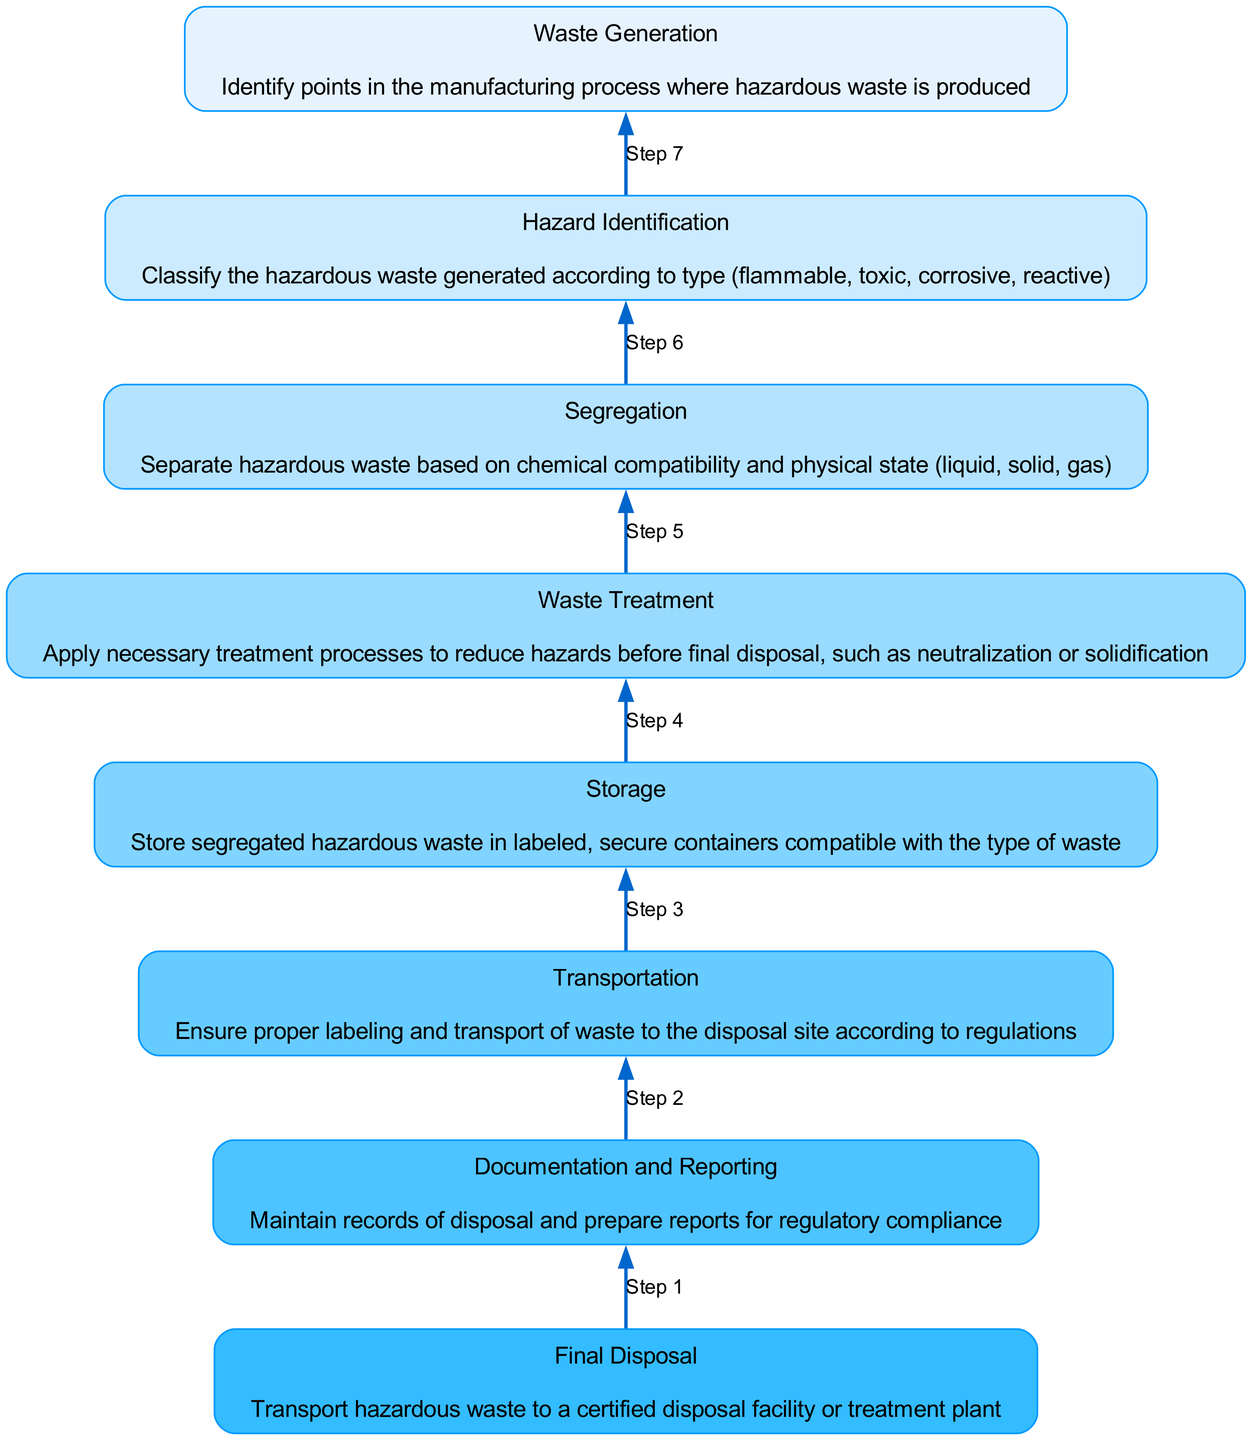What is the last step in the flowchart? The last step in the flowchart is represented by the top node, which is "Documentation and Reporting". This indicates that after final disposal, record-keeping and reporting are necessary.
Answer: Documentation and Reporting How many nodes are present in the flowchart? The flowchart comprises a total of eight nodes, each representing a different step in hazardous waste management.
Answer: Eight Which step precedes "Final Disposal"? The step that directly precedes "Final Disposal" is "Transportation", showing that proper transport is necessary before the final disposal of hazardous waste.
Answer: Transportation What does "Waste Treatment" involve? "Waste Treatment" involves applying necessary processes to reduce hazards, such as neutralization or solidification, before final disposal.
Answer: Treatment processes Which step comes after "Hazard Identification"? The step that follows "Hazard Identification" is "Segregation", indicating that once the hazardous waste is identified, it must be separated based on compatibility and physical state.
Answer: Segregation What color is associated with the node "Storage"? The node "Storage" is colored as per the color palette used, specifically a lighter blue shade. This shade corresponds to the seventh position in the color gradient used throughout the nodes.
Answer: Lighter blue How many steps are required between "Waste Generation" and "Final Disposal"? There are six steps between "Waste Generation" and "Final Disposal," illustrating a systematic process that hazardous waste must undergo before its final disposal.
Answer: Six What is the relationship between "Segregation" and "Waste Treatment"? "Segregation" is a prerequisite for "Waste Treatment", as the waste must first be separated according to type and compatibility before treatment can apply.
Answer: Segregation precedes Treatment 